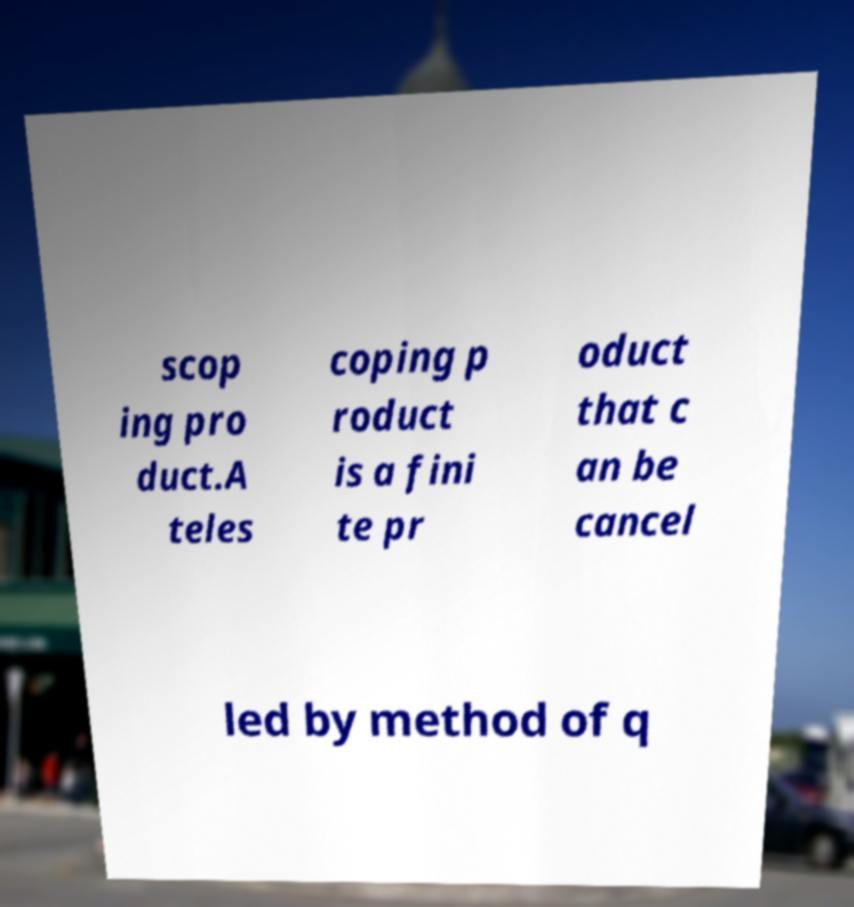Can you accurately transcribe the text from the provided image for me? scop ing pro duct.A teles coping p roduct is a fini te pr oduct that c an be cancel led by method of q 